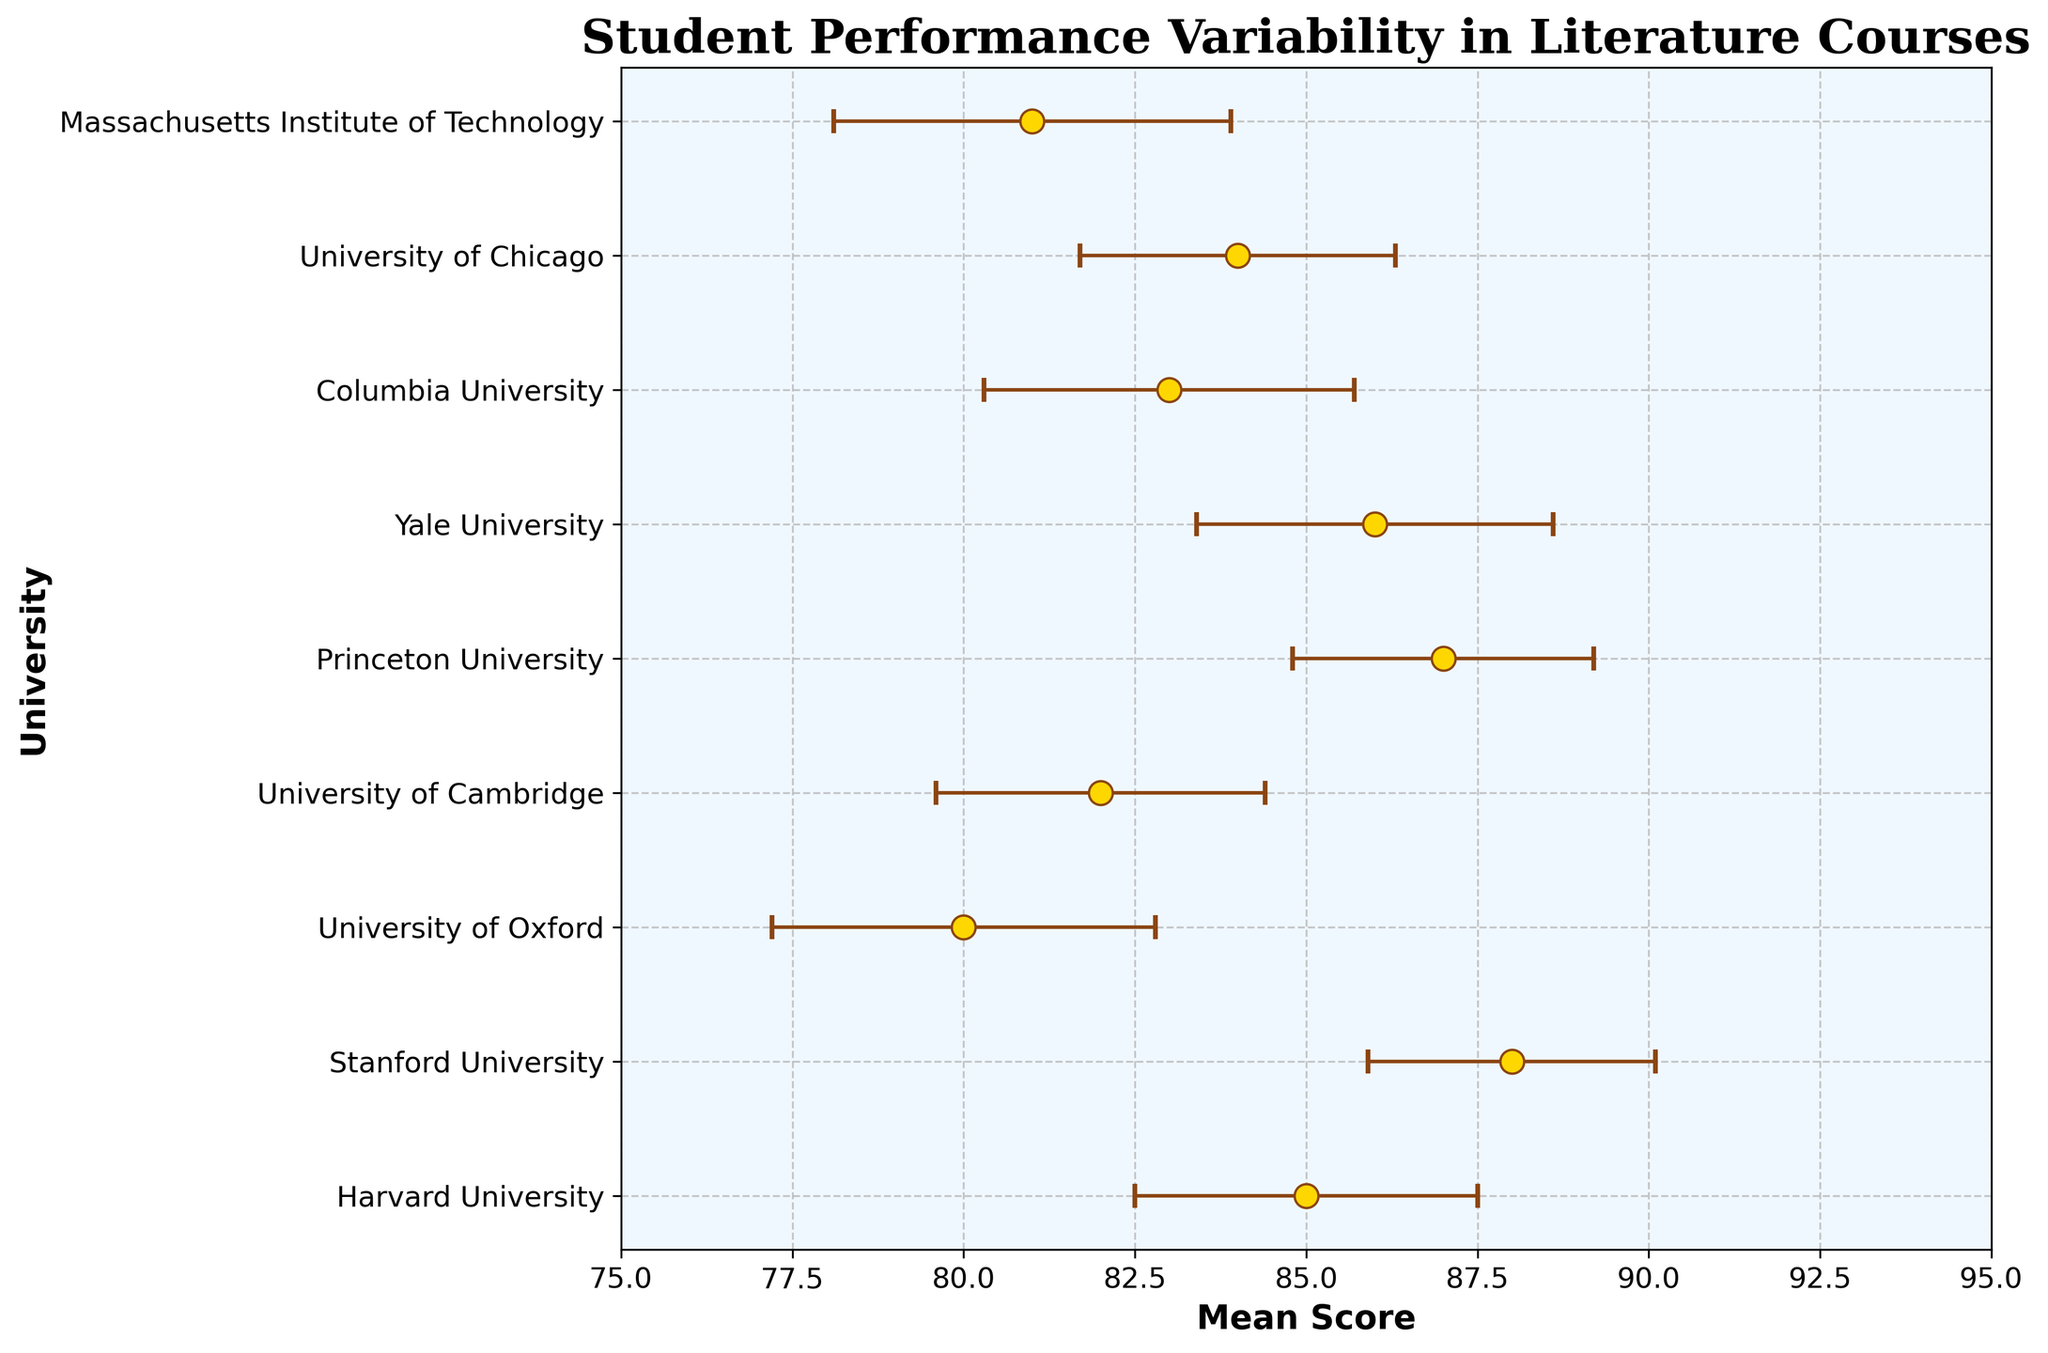What is the mean score for Yale University? The dot plot with error bars indicates the mean score for each university. For Yale University, the mean score is marked by a dot aligned with its label on the y-axis. The mean score for Yale University is 86.
Answer: 86 What are the universities with an average score greater than 85? The plot shows the mean scores for each university. By checking which scores exceed 85, we can identify them. Stanford (88), Harvard (85, though not greater but equal to), Princeton (87), and Yale (86) have scores greater than 85. Excluding Harvard for precision, the others qualify.
Answer: Stanford, Princeton, Yale What is the university with the lowest mean score, and what is that score? The university with the lowest dot on the x-axis of the plot corresponds to the lowest mean score. The University of Oxford has the lowest mean score at 80.
Answer: University of Oxford, 80 How does the performance variability at Columbia University compare with that at the University of Chicago? The performance variability can be assessed by looking at the error bars. Columbia University has a standard error of 2.7, while the University of Chicago has a standard error of 2.3. Columbia University, thus, has higher variability.
Answer: Columbia has higher variability Which university's error bars do not overlap with those of Harvard University? Error bars indicate the range of mean scores considering the standard error. Harvard's score ranges from 82.5 to 87.5. No overlap means the ranges are completely separate. Stanford, Princeton, and MIT do not overlap with Harvard.
Answer: Stanford, Princeton, MIT What is the range of mean scores represented in the plot? The lowest mean score is from the University of Oxford (80), and the highest mean score is from Stanford (88). The range is calculated as the difference between these values.
Answer: 80 to 88 Between Harvard and Yale, which university has a higher average score and by how much? The plot shows that Yale has an average of 86, while Harvard has 85. The difference is calculated by subtracting Harvard's score from Yale's. 86 - 85 = 1.
Answer: Yale by 1 How many universities have a standard error of more than 2.5? By examining the error bars on the plot, which are proportional to the standard errors, we see that University of Oxford (2.8), Yale (2.6), Columbia (2.7), and MIT (2.9) have standard errors exceeding 2.5.
Answer: 4 Which university shows the highest variability in performance, and what is its standard error? The length of the error bars indicates variability. The longest error bar belongs to MIT with a standard error of 2.9, indicating the highest variability.
Answer: MIT, 2.9 